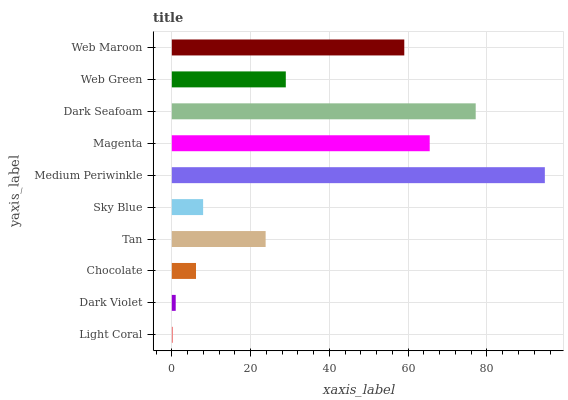Is Light Coral the minimum?
Answer yes or no. Yes. Is Medium Periwinkle the maximum?
Answer yes or no. Yes. Is Dark Violet the minimum?
Answer yes or no. No. Is Dark Violet the maximum?
Answer yes or no. No. Is Dark Violet greater than Light Coral?
Answer yes or no. Yes. Is Light Coral less than Dark Violet?
Answer yes or no. Yes. Is Light Coral greater than Dark Violet?
Answer yes or no. No. Is Dark Violet less than Light Coral?
Answer yes or no. No. Is Web Green the high median?
Answer yes or no. Yes. Is Tan the low median?
Answer yes or no. Yes. Is Chocolate the high median?
Answer yes or no. No. Is Web Maroon the low median?
Answer yes or no. No. 